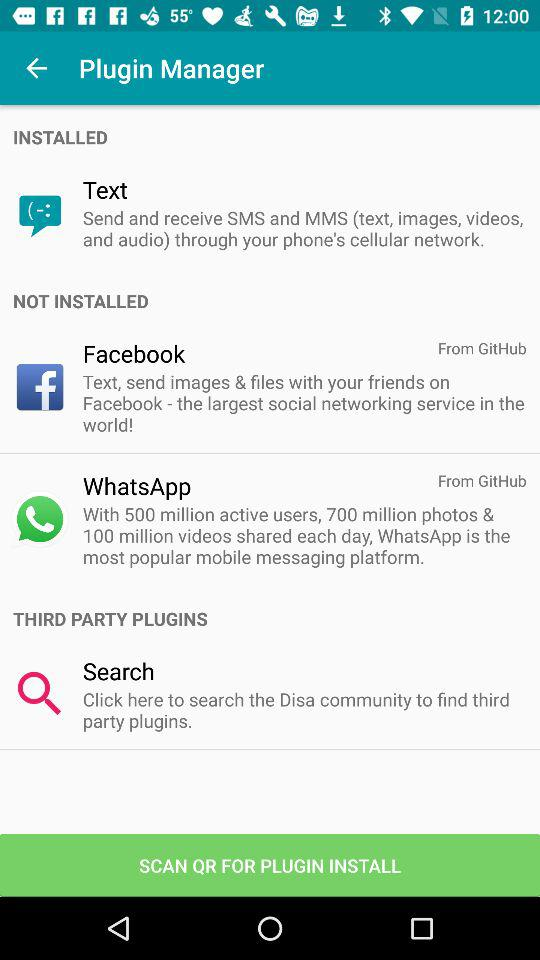What are the names of the plugins that are not installed? The name of the plugins that are not installed are "Facebook" and "WhatsApp". 